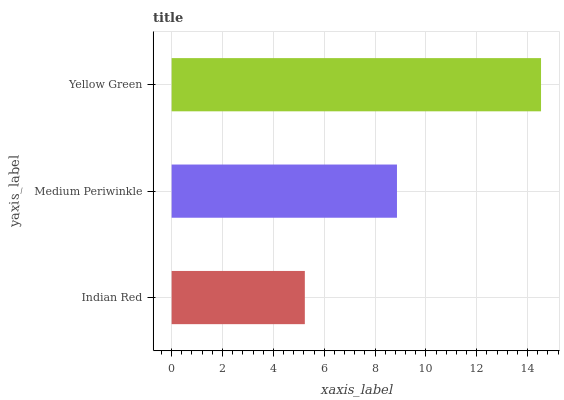Is Indian Red the minimum?
Answer yes or no. Yes. Is Yellow Green the maximum?
Answer yes or no. Yes. Is Medium Periwinkle the minimum?
Answer yes or no. No. Is Medium Periwinkle the maximum?
Answer yes or no. No. Is Medium Periwinkle greater than Indian Red?
Answer yes or no. Yes. Is Indian Red less than Medium Periwinkle?
Answer yes or no. Yes. Is Indian Red greater than Medium Periwinkle?
Answer yes or no. No. Is Medium Periwinkle less than Indian Red?
Answer yes or no. No. Is Medium Periwinkle the high median?
Answer yes or no. Yes. Is Medium Periwinkle the low median?
Answer yes or no. Yes. Is Yellow Green the high median?
Answer yes or no. No. Is Yellow Green the low median?
Answer yes or no. No. 